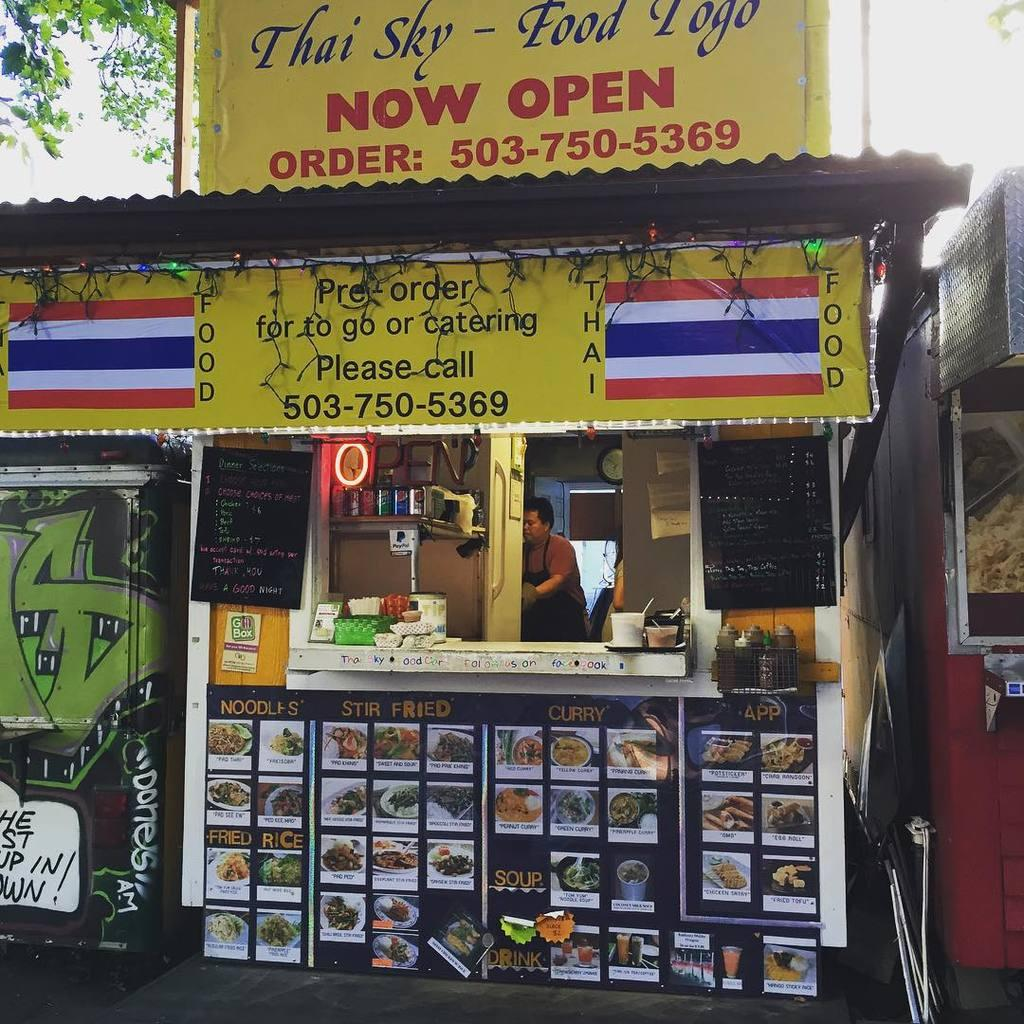What type of establishments can be seen in the image? There are stores in the image. What type of products might be sold in these stores? Beverage tins and spices in plastic containers are present in the image, suggesting that they might sell food and beverage items. How can customers view the available items or services? Menu boards and name boards are present in the image, which might display information about the products or services offered. What might be used to indicate the time in the image? There is a clock in the image. What other items might be used to enhance the flavor of food? Condiments are visible in the image. How might businesses attract customers in the image? Advertisement boards are in the image, which might display promotional messages. What is visible in the background of the image? The sky is visible in the image. How many sheep are visible in the image? There are no sheep present in the image. What color is the gold used for the answer in the image? There is no gold or answer present in the image. 